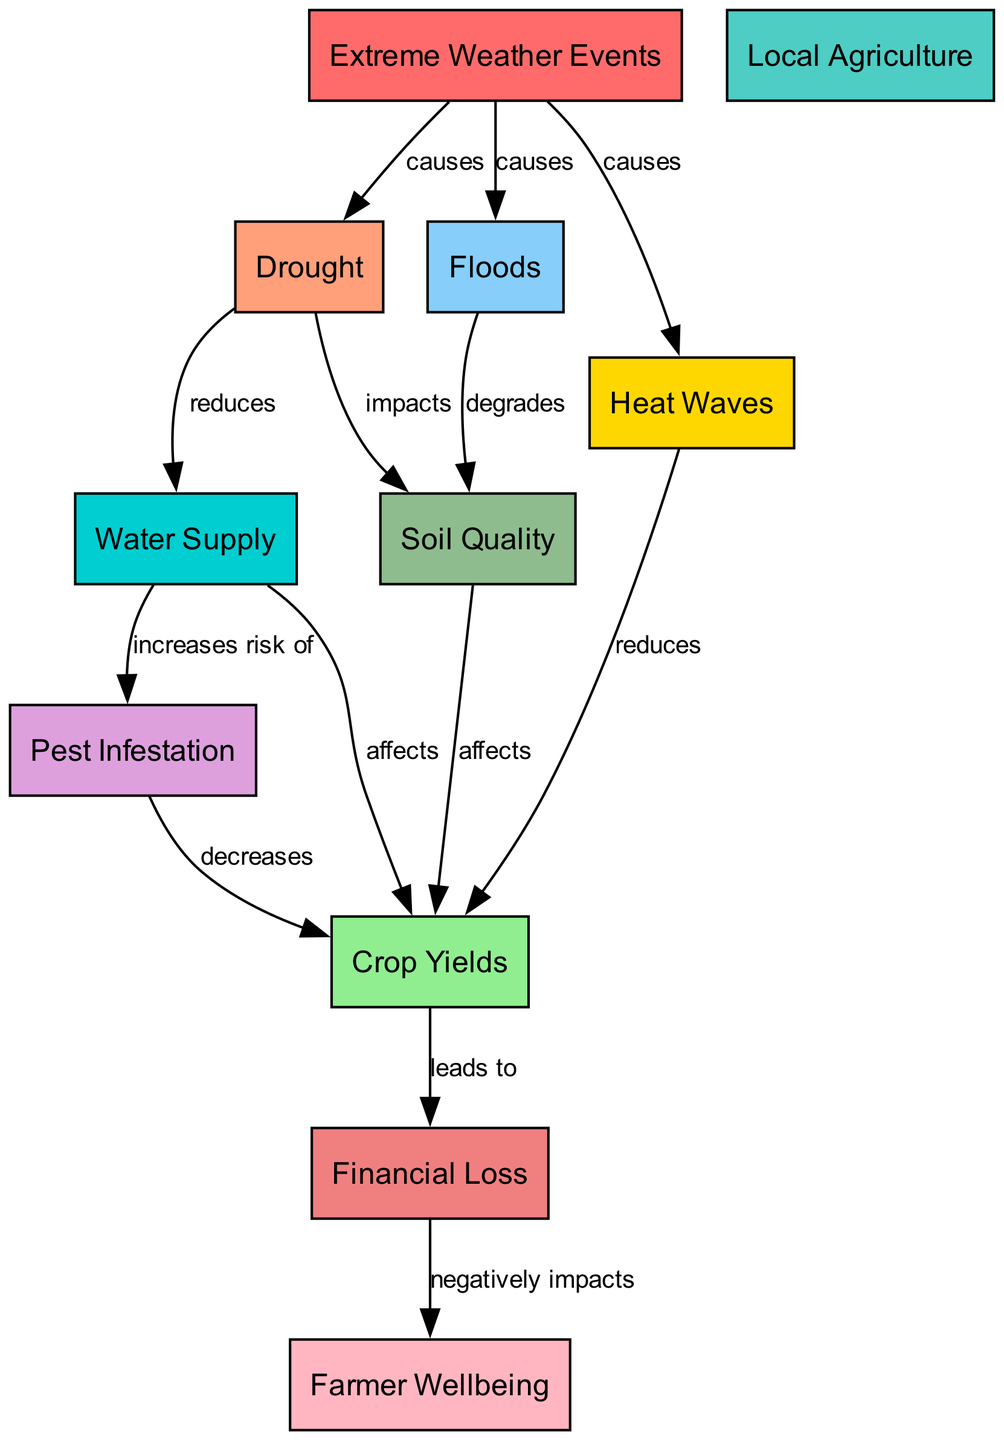What are the extreme weather events mentioned in the diagram? The diagram lists three specific events that are classified as extreme weather events: drought, floods, and heat waves. These are directly connected to the "Extreme Weather Events" node.
Answer: drought, floods, heat waves How does drought impact water supply? In the diagram, there is a direct connection labeled "reduces" between the "drought" node and the "water supply" node, indicating that drought has a negative effect on water supply.
Answer: reduces What is the relationship between floods and soil quality? The diagram shows a connection from the "floods" node to the "soil quality" node, labeled "degrades," indicating that floods have a degrading effect on soil quality.
Answer: degrades How many nodes are in the diagram? By counting the distinct labeled nodes listed in the diagram, there are eleven nodes that represent various concepts related to the effects of extreme weather on local agriculture.
Answer: eleven What effect do heat waves have on crop yields? The diagram indicates that heat waves directly "reduces" crop yields, as illustrated by the directed edge from the "heat waves" node to the "crop yields" node.
Answer: reduces What does financial loss negatively impact? According to the diagram, financial loss has a direct connection to "farmer wellbeing," indicating that it negatively impacts farmer wellbeing as shown by the edge labeled "negatively impacts."
Answer: farmer wellbeing How does high water supply affect pest infestation? The diagram shows an edge from the "water supply" node to the "pest infestation" node, labeled "increases risk of," which suggests that an abundance of water may increase the risk of pest infestation.
Answer: increases risk of What is the consequence of poor soil quality on crop yields? The diagram reflects that soil quality affects crop yields through a direct edge labeled "affects," indicating that poor soil quality can lead to lower crop yields.
Answer: affects What flow results from extreme weather events to financial loss? Starting from the "extreme weather events" node, the flow through the nodes indicates that these events cause drought, floods, and heat waves which subsequently impact soil quality and water supply, then lead to reduced crop yields and ultimately result in financial loss. This illustrates a chain reaction from extreme weather to financial loss.
Answer: chain reaction from extreme weather to financial loss 